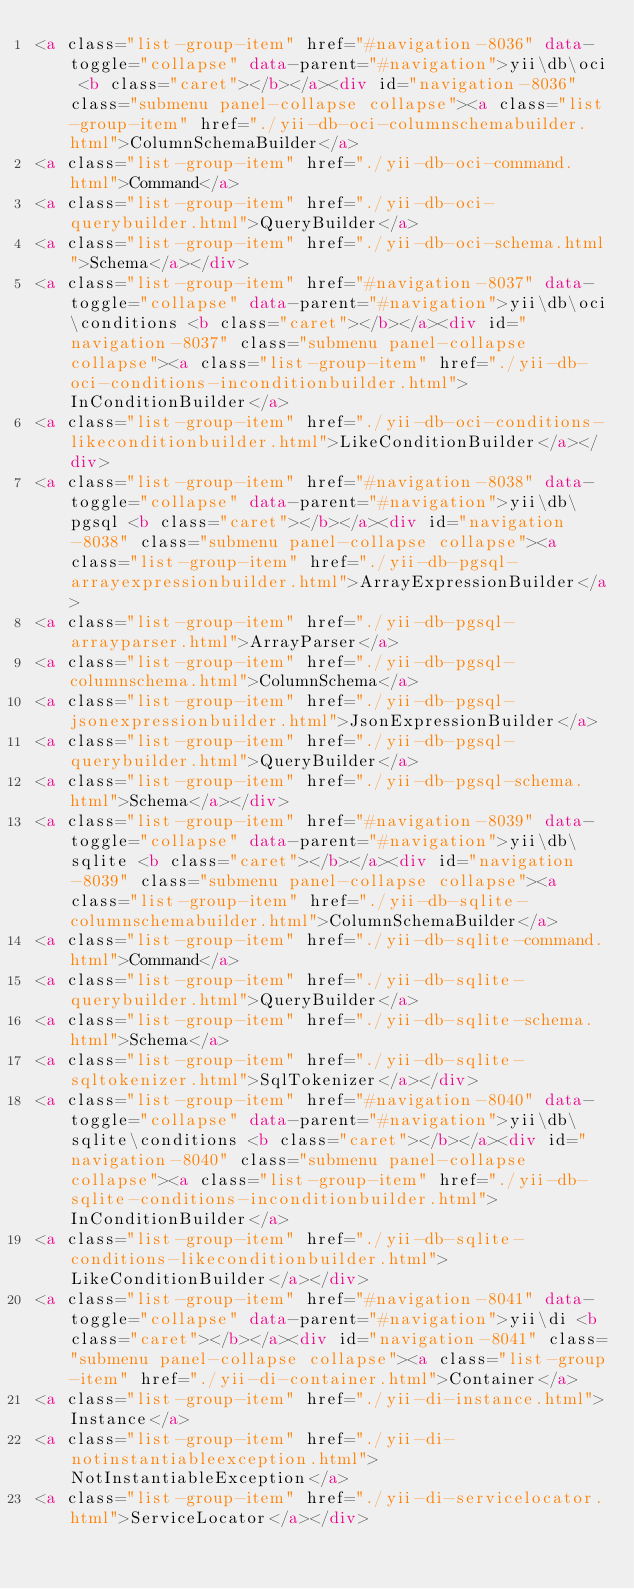Convert code to text. <code><loc_0><loc_0><loc_500><loc_500><_HTML_><a class="list-group-item" href="#navigation-8036" data-toggle="collapse" data-parent="#navigation">yii\db\oci <b class="caret"></b></a><div id="navigation-8036" class="submenu panel-collapse collapse"><a class="list-group-item" href="./yii-db-oci-columnschemabuilder.html">ColumnSchemaBuilder</a>
<a class="list-group-item" href="./yii-db-oci-command.html">Command</a>
<a class="list-group-item" href="./yii-db-oci-querybuilder.html">QueryBuilder</a>
<a class="list-group-item" href="./yii-db-oci-schema.html">Schema</a></div>
<a class="list-group-item" href="#navigation-8037" data-toggle="collapse" data-parent="#navigation">yii\db\oci\conditions <b class="caret"></b></a><div id="navigation-8037" class="submenu panel-collapse collapse"><a class="list-group-item" href="./yii-db-oci-conditions-inconditionbuilder.html">InConditionBuilder</a>
<a class="list-group-item" href="./yii-db-oci-conditions-likeconditionbuilder.html">LikeConditionBuilder</a></div>
<a class="list-group-item" href="#navigation-8038" data-toggle="collapse" data-parent="#navigation">yii\db\pgsql <b class="caret"></b></a><div id="navigation-8038" class="submenu panel-collapse collapse"><a class="list-group-item" href="./yii-db-pgsql-arrayexpressionbuilder.html">ArrayExpressionBuilder</a>
<a class="list-group-item" href="./yii-db-pgsql-arrayparser.html">ArrayParser</a>
<a class="list-group-item" href="./yii-db-pgsql-columnschema.html">ColumnSchema</a>
<a class="list-group-item" href="./yii-db-pgsql-jsonexpressionbuilder.html">JsonExpressionBuilder</a>
<a class="list-group-item" href="./yii-db-pgsql-querybuilder.html">QueryBuilder</a>
<a class="list-group-item" href="./yii-db-pgsql-schema.html">Schema</a></div>
<a class="list-group-item" href="#navigation-8039" data-toggle="collapse" data-parent="#navigation">yii\db\sqlite <b class="caret"></b></a><div id="navigation-8039" class="submenu panel-collapse collapse"><a class="list-group-item" href="./yii-db-sqlite-columnschemabuilder.html">ColumnSchemaBuilder</a>
<a class="list-group-item" href="./yii-db-sqlite-command.html">Command</a>
<a class="list-group-item" href="./yii-db-sqlite-querybuilder.html">QueryBuilder</a>
<a class="list-group-item" href="./yii-db-sqlite-schema.html">Schema</a>
<a class="list-group-item" href="./yii-db-sqlite-sqltokenizer.html">SqlTokenizer</a></div>
<a class="list-group-item" href="#navigation-8040" data-toggle="collapse" data-parent="#navigation">yii\db\sqlite\conditions <b class="caret"></b></a><div id="navigation-8040" class="submenu panel-collapse collapse"><a class="list-group-item" href="./yii-db-sqlite-conditions-inconditionbuilder.html">InConditionBuilder</a>
<a class="list-group-item" href="./yii-db-sqlite-conditions-likeconditionbuilder.html">LikeConditionBuilder</a></div>
<a class="list-group-item" href="#navigation-8041" data-toggle="collapse" data-parent="#navigation">yii\di <b class="caret"></b></a><div id="navigation-8041" class="submenu panel-collapse collapse"><a class="list-group-item" href="./yii-di-container.html">Container</a>
<a class="list-group-item" href="./yii-di-instance.html">Instance</a>
<a class="list-group-item" href="./yii-di-notinstantiableexception.html">NotInstantiableException</a>
<a class="list-group-item" href="./yii-di-servicelocator.html">ServiceLocator</a></div></code> 